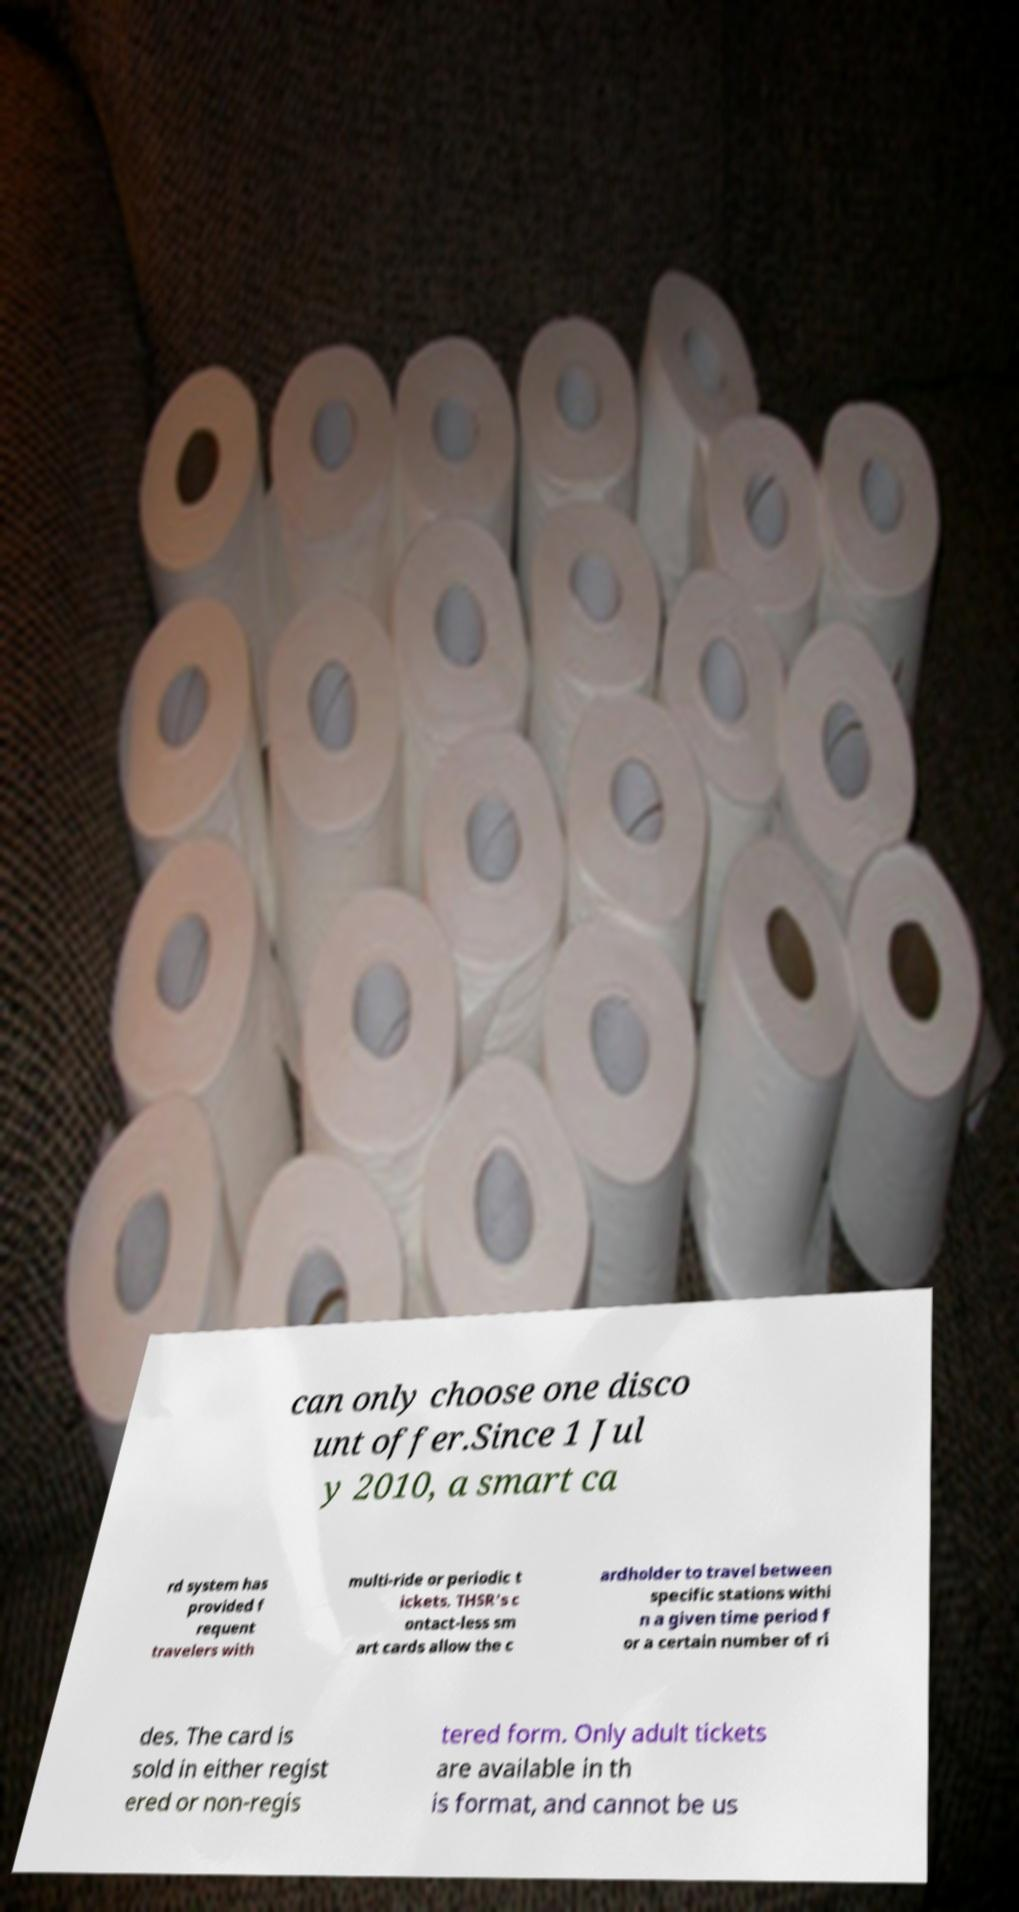What messages or text are displayed in this image? I need them in a readable, typed format. can only choose one disco unt offer.Since 1 Jul y 2010, a smart ca rd system has provided f requent travelers with multi-ride or periodic t ickets. THSR's c ontact-less sm art cards allow the c ardholder to travel between specific stations withi n a given time period f or a certain number of ri des. The card is sold in either regist ered or non-regis tered form. Only adult tickets are available in th is format, and cannot be us 